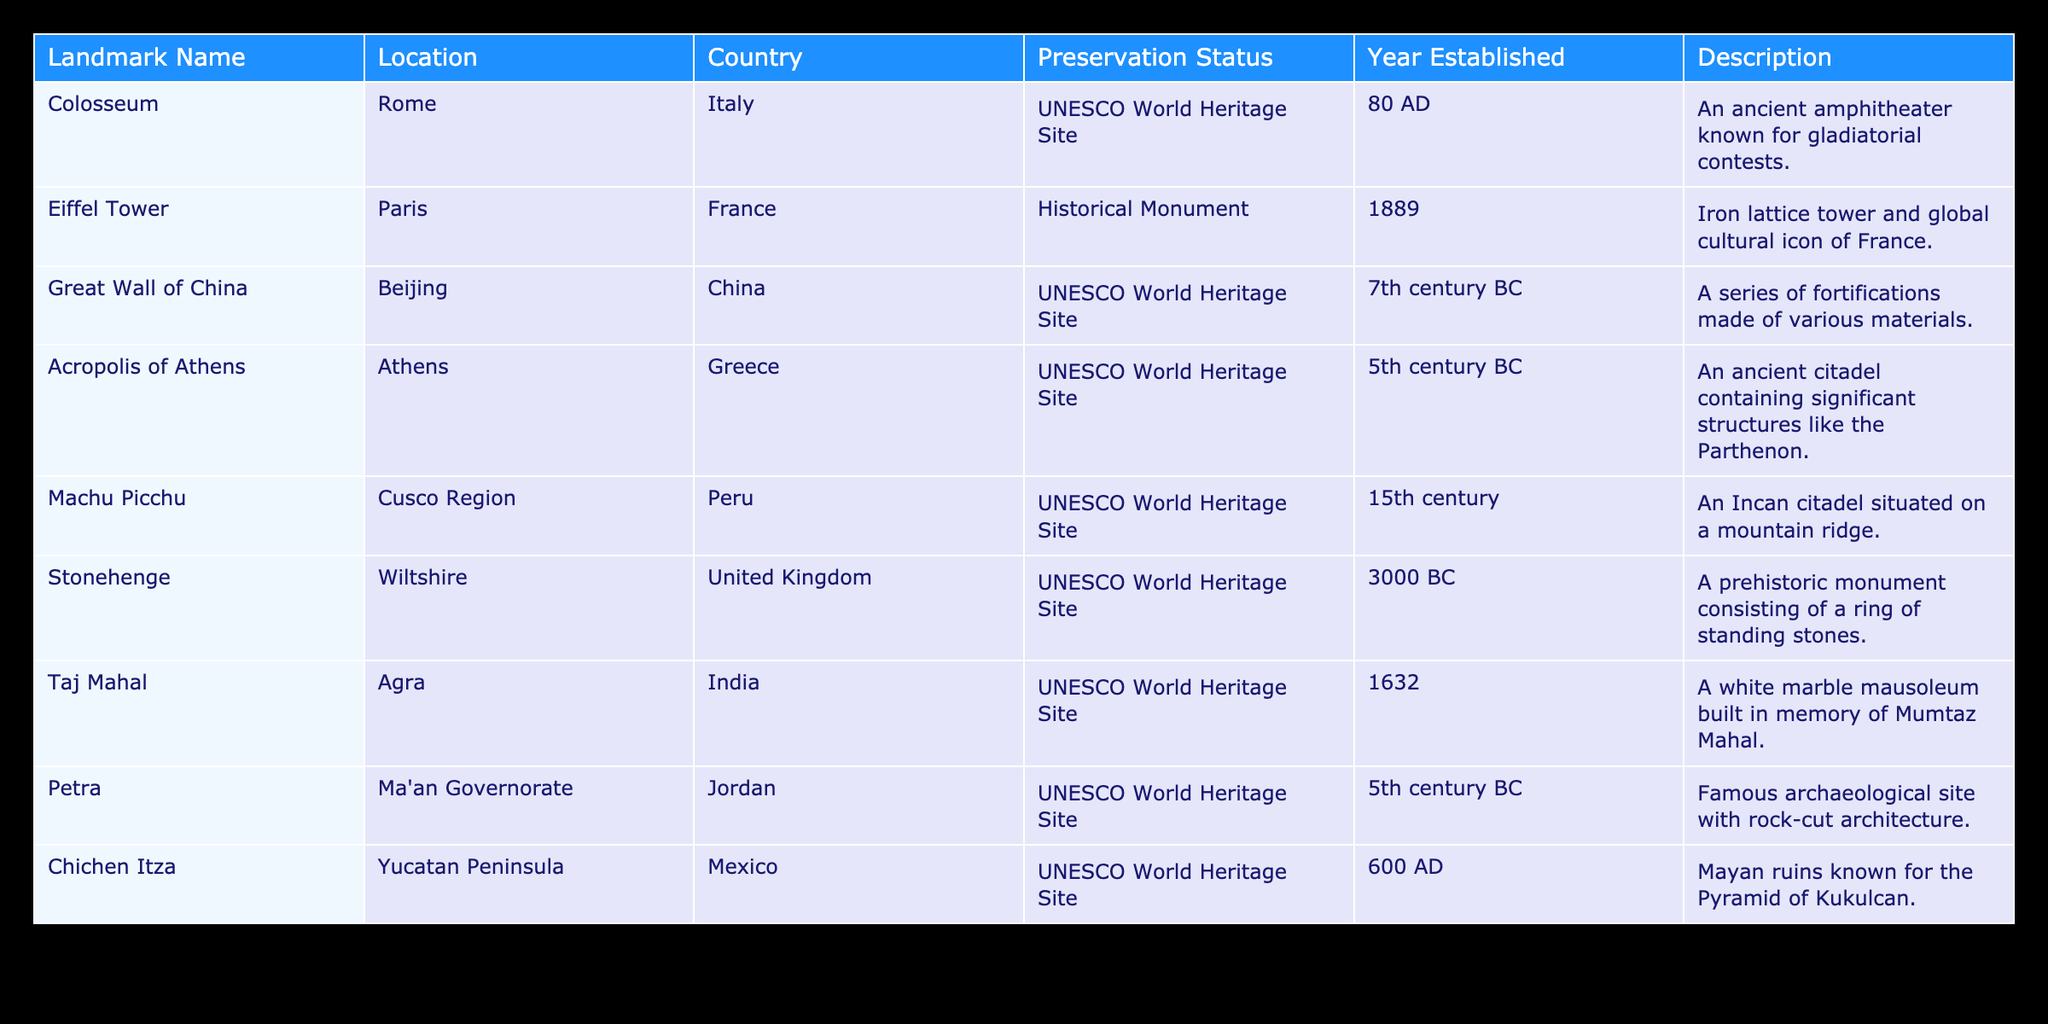What is the preservation status of the Great Wall of China? The preservation status is listed in the table under the "Preservation Status" column for the Great Wall of China, which indicates that it is a UNESCO World Heritage Site.
Answer: UNESCO World Heritage Site How many landmarks are designated as UNESCO World Heritage Sites? By counting the rows in the "Preservation Status" column, we see that there are 7 landmarks marked as UNESCO World Heritage Sites.
Answer: 7 Is the Taj Mahal established before the Colosseum? To answer this question, we need to compare the "Year Established" of each landmark. The Taj Mahal was established in 1632, while the Colosseum was established in 80 AD, so the Taj Mahal is not established before the Colosseum.
Answer: No Which landmark is located in Jordan? The table lists the location for each landmark, and in the row for Petra, it indicates that this landmark is located in Ma'an Governorate, Jordan.
Answer: Petra What is the earliest established landmark on the list? We can determine this by looking at the "Year Established" column. The earliest year listed is 3000 BC for Stonehenge, so it is the earliest established landmark.
Answer: Stonehenge How many landmarks in the table were established in the 5th century BC? From the table, we can see that both the Acropolis of Athens and Petra were established in the 5th century BC, giving us a total of 2 landmarks.
Answer: 2 Does the Eiffel Tower have UNESCO status? We can check the "Preservation Status" for the Eiffel Tower and see that it is marked as a Historical Monument. Therefore, it does not have UNESCO status.
Answer: No Which countries have landmarks that are UNESCO World Heritage Sites? By examining the "Country" column associated with the UNESCO World Heritage Sites, we find the following countries listed: Italy, China, Greece, Peru, Jordan, Mexico, and India.
Answer: Italy, China, Greece, Peru, Jordan, Mexico, India What is the average year established for the landmarks listed in the table? To find the average, we need to convert the years to numerical format (considering BC as negative): (80 + 1889 + -700 + -500 + 1475 + -3000 + 1632 + -500 + 600) / 9 = -1143.89, thus the average is approximately 1144 BC.
Answer: Approximately 1144 BC 